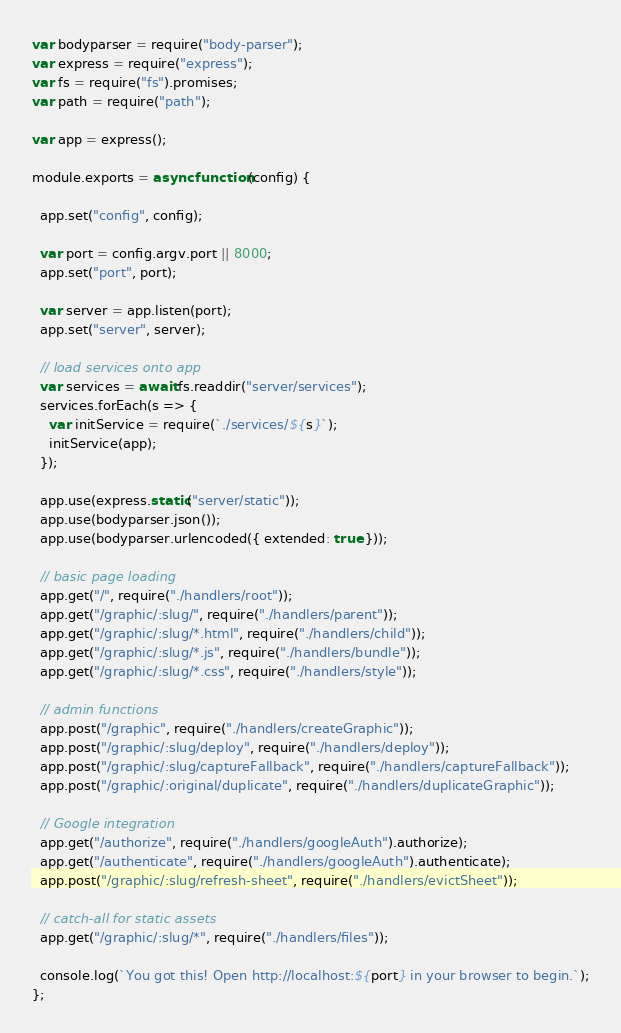Convert code to text. <code><loc_0><loc_0><loc_500><loc_500><_JavaScript_>var bodyparser = require("body-parser");
var express = require("express");
var fs = require("fs").promises;
var path = require("path");

var app = express();

module.exports = async function(config) {

  app.set("config", config);

  var port = config.argv.port || 8000;
  app.set("port", port);

  var server = app.listen(port);
  app.set("server", server);

  // load services onto app
  var services = await fs.readdir("server/services");
  services.forEach(s => {
    var initService = require(`./services/${s}`);
    initService(app);
  });

  app.use(express.static("server/static"));
  app.use(bodyparser.json());
  app.use(bodyparser.urlencoded({ extended: true }));

  // basic page loading
  app.get("/", require("./handlers/root"));
  app.get("/graphic/:slug/", require("./handlers/parent"));
  app.get("/graphic/:slug/*.html", require("./handlers/child"));
  app.get("/graphic/:slug/*.js", require("./handlers/bundle"));
  app.get("/graphic/:slug/*.css", require("./handlers/style"));

  // admin functions
  app.post("/graphic", require("./handlers/createGraphic"));
  app.post("/graphic/:slug/deploy", require("./handlers/deploy"));
  app.post("/graphic/:slug/captureFallback", require("./handlers/captureFallback"));
  app.post("/graphic/:original/duplicate", require("./handlers/duplicateGraphic"));

  // Google integration
  app.get("/authorize", require("./handlers/googleAuth").authorize);
  app.get("/authenticate", require("./handlers/googleAuth").authenticate);
  app.post("/graphic/:slug/refresh-sheet", require("./handlers/evictSheet"));

  // catch-all for static assets
  app.get("/graphic/:slug/*", require("./handlers/files"));

  console.log(`You got this! Open http://localhost:${port} in your browser to begin.`);
};
</code> 